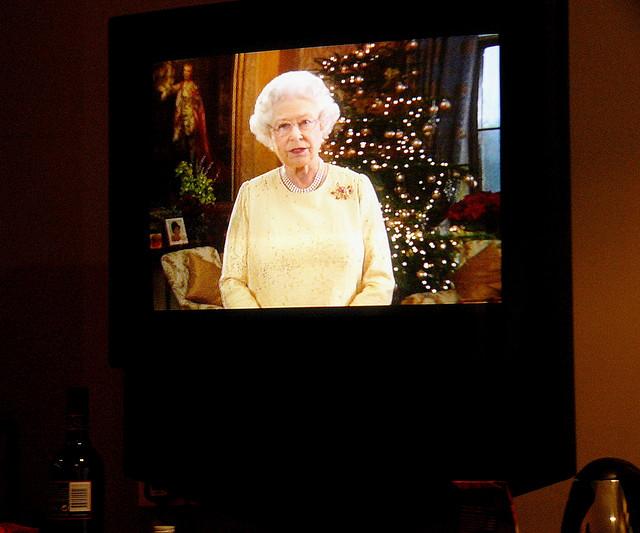What does the woman wear around her neck?
Keep it brief. Necklace. Is the television on or off?
Concise answer only. On. Is she asian?
Answer briefly. No. Who is on the television?
Be succinct. Queen elizabeth. What color is the woman's sweater?
Short answer required. Yellow. 